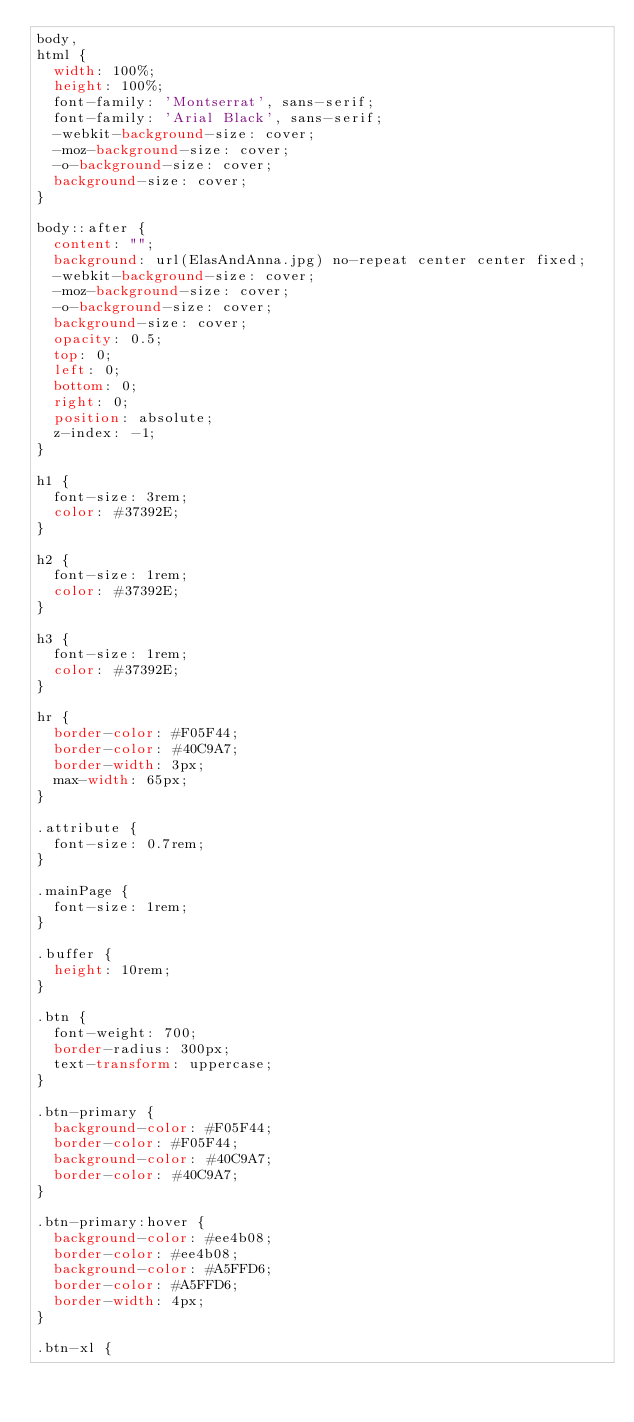<code> <loc_0><loc_0><loc_500><loc_500><_CSS_>body,
html {
  width: 100%;
  height: 100%;
  font-family: 'Montserrat', sans-serif;
  font-family: 'Arial Black', sans-serif;
  -webkit-background-size: cover;
  -moz-background-size: cover;
  -o-background-size: cover;
  background-size: cover;
}

body::after {
  content: "";
  background: url(ElasAndAnna.jpg) no-repeat center center fixed;
  -webkit-background-size: cover;
  -moz-background-size: cover;
  -o-background-size: cover;
  background-size: cover;
  opacity: 0.5;
  top: 0;
  left: 0;
  bottom: 0;
  right: 0;
  position: absolute;
  z-index: -1;   
}

h1 {
  font-size: 3rem;
  color: #37392E;
}

h2 {
  font-size: 1rem;
  color: #37392E;
}

h3 {
  font-size: 1rem;
  color: #37392E;
}

hr {
  border-color: #F05F44;
  border-color: #40C9A7;
  border-width: 3px;
  max-width: 65px;
}

.attribute {
  font-size: 0.7rem;
}

.mainPage {
  font-size: 1rem;
}

.buffer {
  height: 10rem;
}

.btn {
  font-weight: 700;
  border-radius: 300px;
  text-transform: uppercase;
}

.btn-primary {
  background-color: #F05F44;
  border-color: #F05F44;
  background-color: #40C9A7;
  border-color: #40C9A7;
}

.btn-primary:hover {
  background-color: #ee4b08;
  border-color: #ee4b08;
  background-color: #A5FFD6;
  border-color: #A5FFD6;
  border-width: 4px;
}

.btn-xl {</code> 